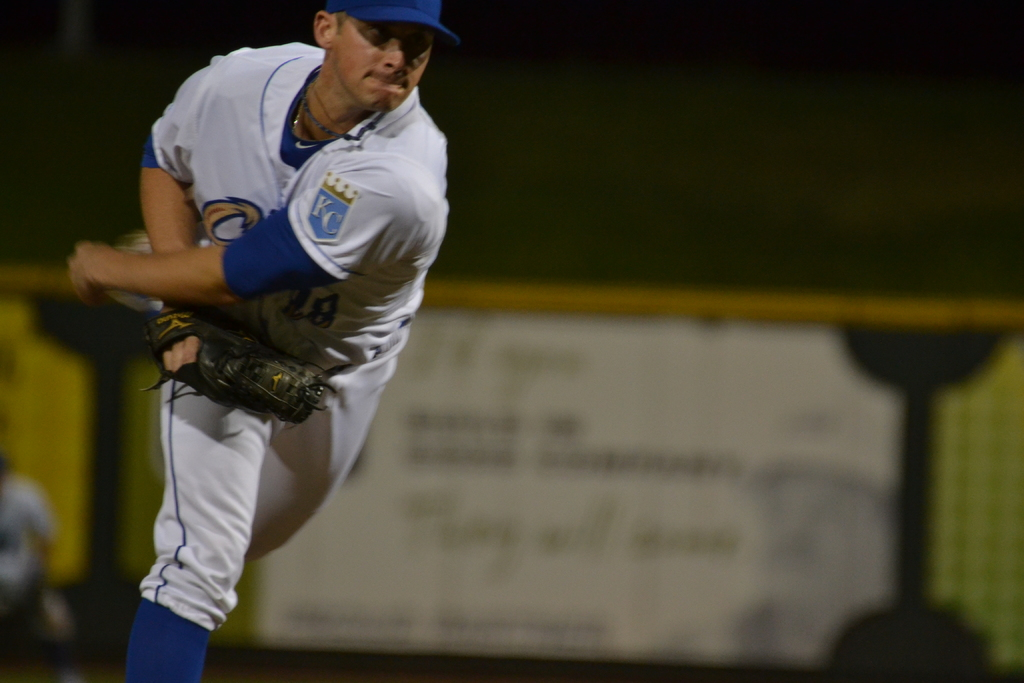What can you infer about the game's intensity from the athlete's body language? The pitcher's focused expression and aggressive posture, with a powerful throw gesture, suggest a high-stakes moment in the game, indicating high intensity and competitiveness. 